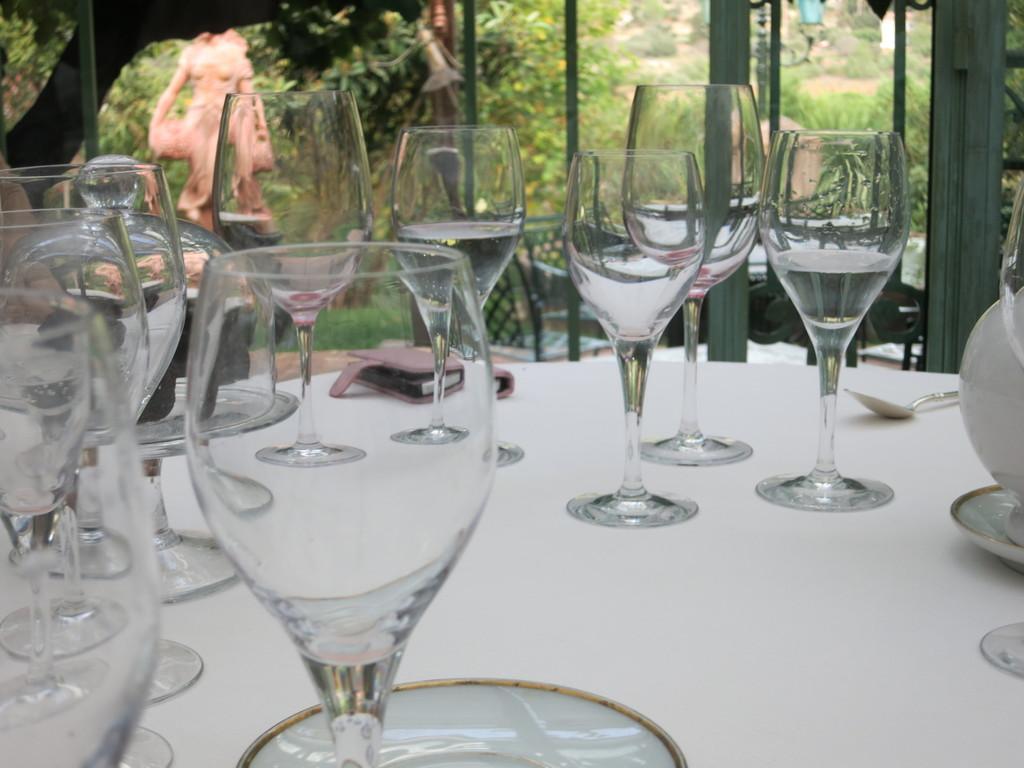Describe this image in one or two sentences. There are some glasses,spoon and a valet on a table. There is a window glass frame in the background. 